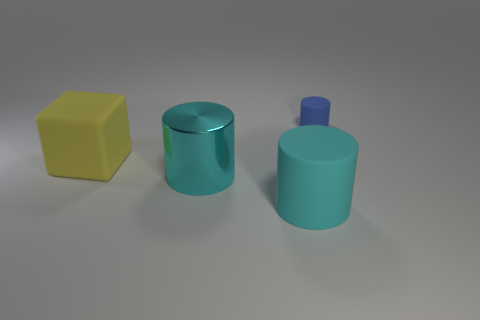Is there anything else that is the same shape as the yellow rubber thing?
Offer a terse response. No. How many other things are there of the same color as the large matte cylinder?
Your answer should be very brief. 1. What shape is the yellow object that is the same size as the cyan rubber thing?
Provide a succinct answer. Cube. What number of large things are either metallic cylinders or yellow blocks?
Ensure brevity in your answer.  2. Is there a cylinder that is left of the tiny blue matte object behind the large thing in front of the metal thing?
Provide a short and direct response. Yes. Is there a gray matte object of the same size as the metal object?
Provide a succinct answer. No. What is the material of the cyan cylinder that is the same size as the cyan rubber thing?
Your response must be concise. Metal. There is a yellow matte block; is it the same size as the cyan cylinder behind the large cyan rubber object?
Your answer should be very brief. Yes. What number of shiny things are either blue things or yellow things?
Your answer should be very brief. 0. What number of other tiny cyan objects are the same shape as the cyan rubber object?
Your answer should be very brief. 0. 